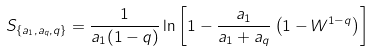<formula> <loc_0><loc_0><loc_500><loc_500>S _ { \{ a _ { 1 } , a _ { q } , q \} } = \frac { 1 } { a _ { 1 } ( 1 - q ) } \ln \left [ 1 - \frac { a _ { 1 } } { a _ { 1 } + a _ { q } } \left ( 1 - W ^ { 1 - q } \right ) \right ]</formula> 